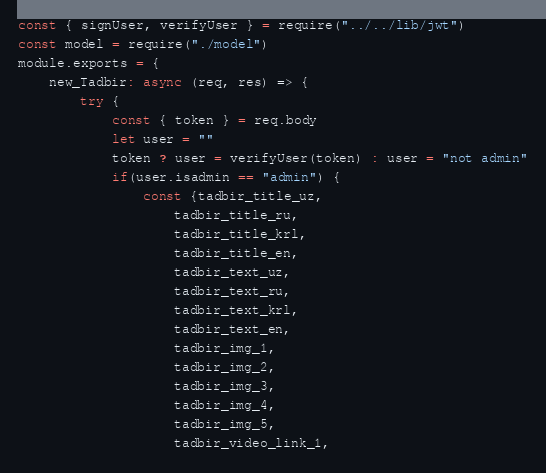<code> <loc_0><loc_0><loc_500><loc_500><_JavaScript_>const { signUser, verifyUser } = require("../../lib/jwt")
const model = require("./model")
module.exports = {
    new_Tadbir: async (req, res) => {
        try {  
            const { token } = req.body 
            let user = ""
            token ? user = verifyUser(token) : user = "not admin"
            if(user.isadmin == "admin") {
                const {tadbir_title_uz, 
                    tadbir_title_ru, 
                    tadbir_title_krl, 
                    tadbir_title_en, 
                    tadbir_text_uz,
                    tadbir_text_ru,
                    tadbir_text_krl,
                    tadbir_text_en,
                    tadbir_img_1,
                    tadbir_img_2,
                    tadbir_img_3,
                    tadbir_img_4,
                    tadbir_img_5,
                    tadbir_video_link_1,</code> 